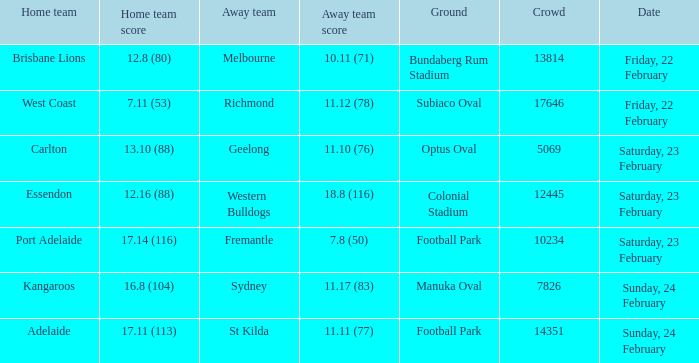When did the guest team fremantle have their match? Saturday, 23 February. 